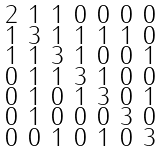<formula> <loc_0><loc_0><loc_500><loc_500>\begin{smallmatrix} 2 & 1 & 1 & 0 & 0 & 0 & 0 \\ 1 & 3 & 1 & 1 & 1 & 1 & 0 \\ 1 & 1 & 3 & 1 & 0 & 0 & 1 \\ 0 & 1 & 1 & 3 & 1 & 0 & 0 \\ 0 & 1 & 0 & 1 & 3 & 0 & 1 \\ 0 & 1 & 0 & 0 & 0 & 3 & 0 \\ 0 & 0 & 1 & 0 & 1 & 0 & 3 \end{smallmatrix}</formula> 